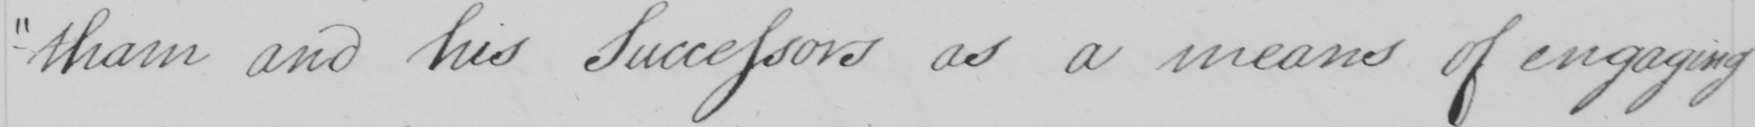Can you read and transcribe this handwriting? -tham and his Successors as a means of engaging 